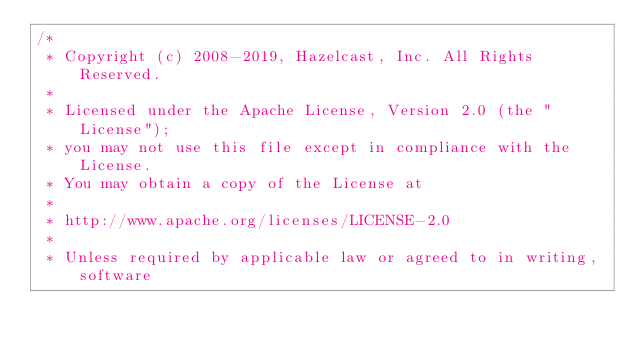<code> <loc_0><loc_0><loc_500><loc_500><_Java_>/*
 * Copyright (c) 2008-2019, Hazelcast, Inc. All Rights Reserved.
 *
 * Licensed under the Apache License, Version 2.0 (the "License");
 * you may not use this file except in compliance with the License.
 * You may obtain a copy of the License at
 *
 * http://www.apache.org/licenses/LICENSE-2.0
 *
 * Unless required by applicable law or agreed to in writing, software</code> 